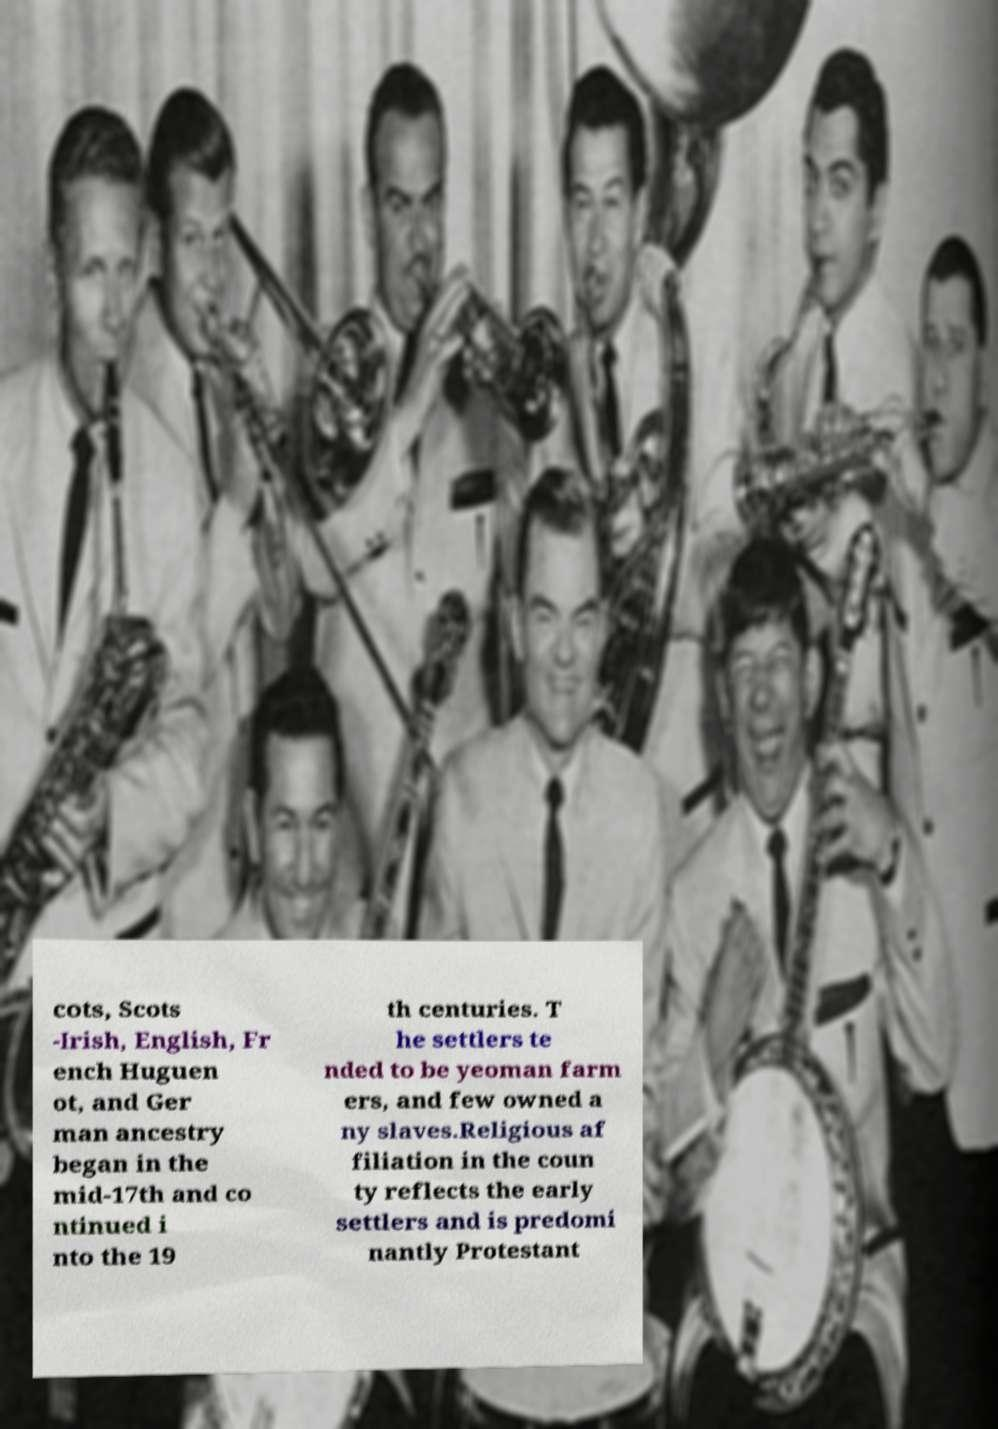Could you extract and type out the text from this image? cots, Scots -Irish, English, Fr ench Huguen ot, and Ger man ancestry began in the mid-17th and co ntinued i nto the 19 th centuries. T he settlers te nded to be yeoman farm ers, and few owned a ny slaves.Religious af filiation in the coun ty reflects the early settlers and is predomi nantly Protestant 